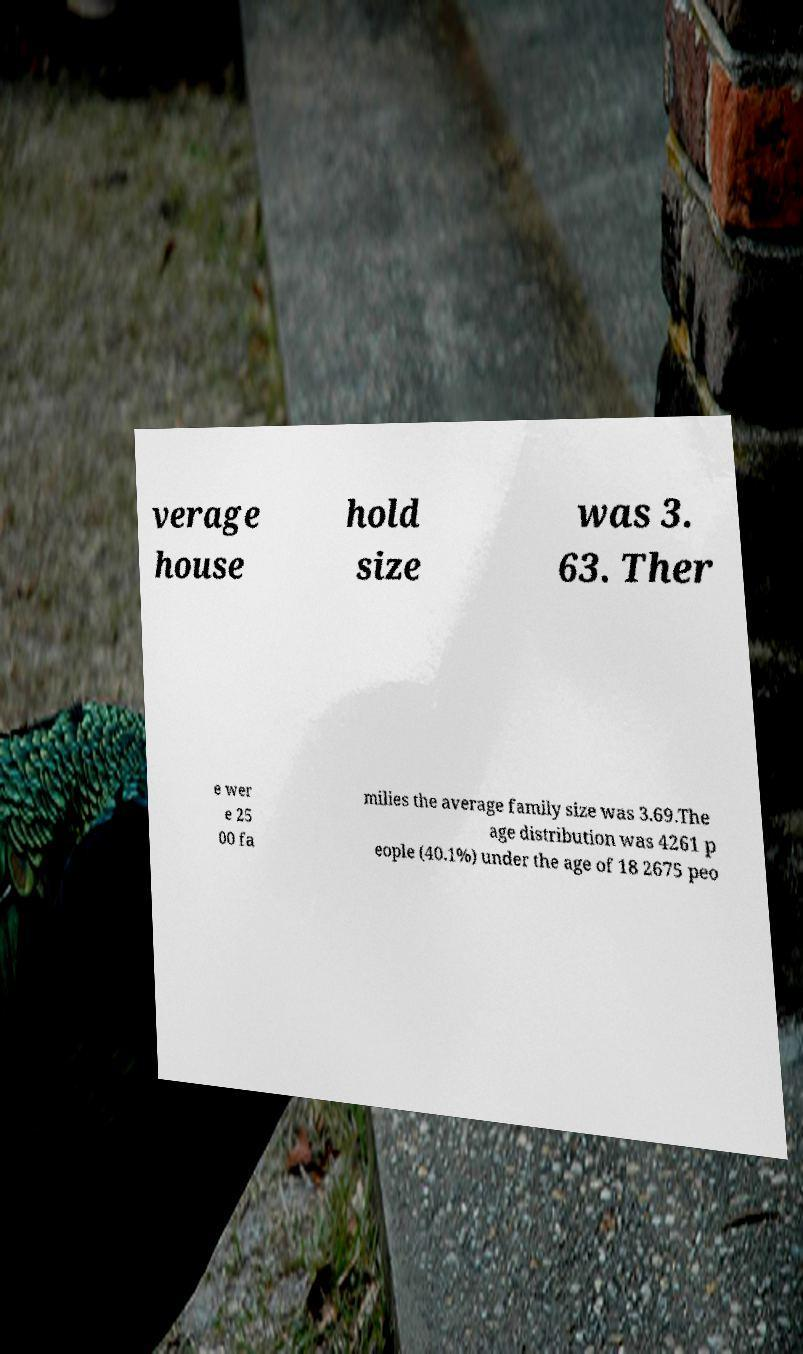Can you accurately transcribe the text from the provided image for me? verage house hold size was 3. 63. Ther e wer e 25 00 fa milies the average family size was 3.69.The age distribution was 4261 p eople (40.1%) under the age of 18 2675 peo 